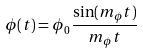Convert formula to latex. <formula><loc_0><loc_0><loc_500><loc_500>\phi ( t ) = \phi _ { 0 } \frac { \sin ( m _ { \phi } t ) } { m _ { \phi } t }</formula> 